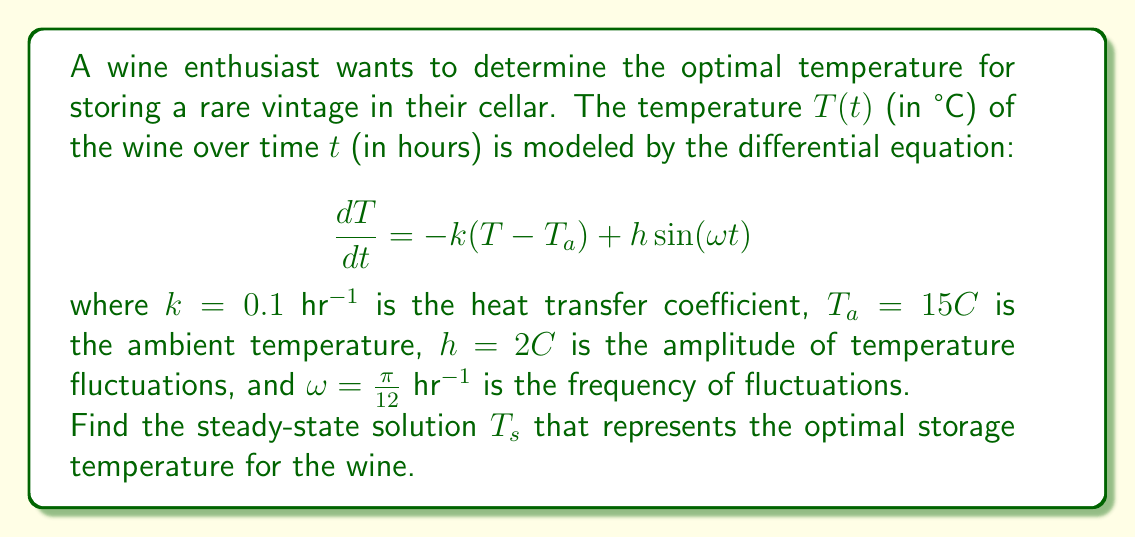Can you answer this question? To find the steady-state solution, we need to follow these steps:

1) The steady-state solution is the long-term behavior of the system when it's not changing over time. Mathematically, this means $\frac{dT}{dt} = 0$.

2) Set the derivative to zero in the original equation:

   $$0 = -k(T_s - T_a) + h\sin(\omega t)$$

3) The sine term represents fluctuations around the steady state. In the long term, these fluctuations average out to zero. So we can ignore this term for the steady-state solution:

   $$0 = -k(T_s - T_a)$$

4) Solve for $T_s$:

   $$k(T_s - T_a) = 0$$
   $$T_s - T_a = 0$$
   $$T_s = T_a$$

5) Substitute the given value for $T_a$:

   $$T_s = 15°C$$

This result indicates that the optimal storage temperature for the wine in this cellar is equal to the ambient temperature of 15°C, which is indeed a suitable temperature for long-term wine storage.
Answer: $T_s = 15°C$ 